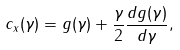Convert formula to latex. <formula><loc_0><loc_0><loc_500><loc_500>c _ { x } ( \gamma ) = g ( \gamma ) + \frac { \gamma } { 2 } \frac { d g ( \gamma ) } { d \gamma } ,</formula> 